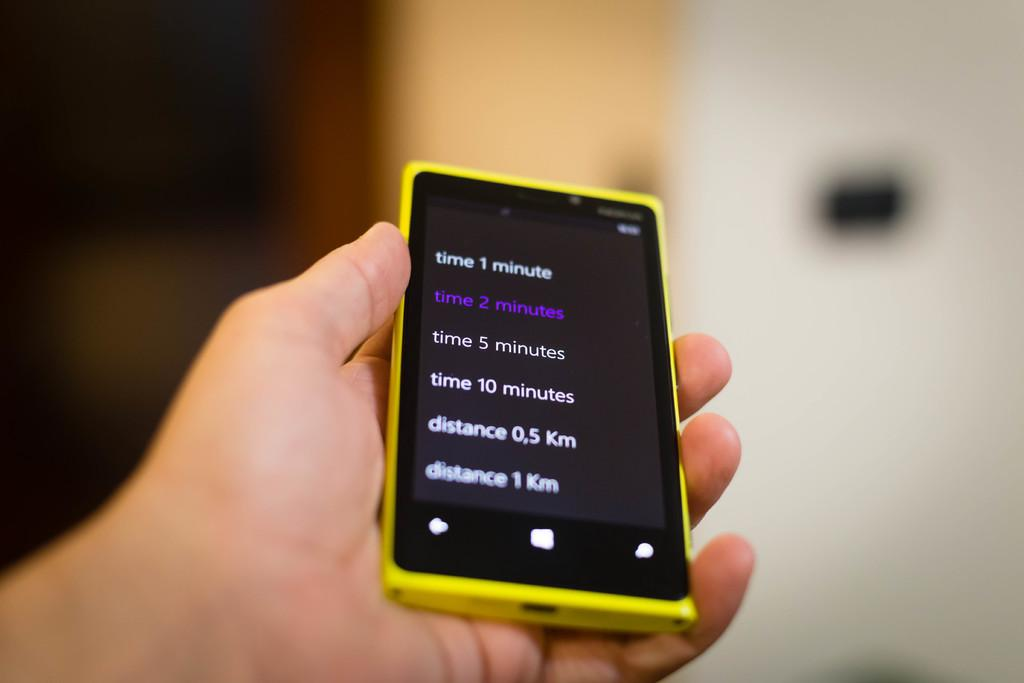What can be seen in the image that belongs to a person? There is a person's hand in the image. What is the hand holding? The hand is holding a yellow mobile. Can you describe the background of the image? The background of the image is blurred. What type of liquid is being poured from the box in the image? There is no box or liquid present in the image; it only features a person's hand holding a yellow mobile. 